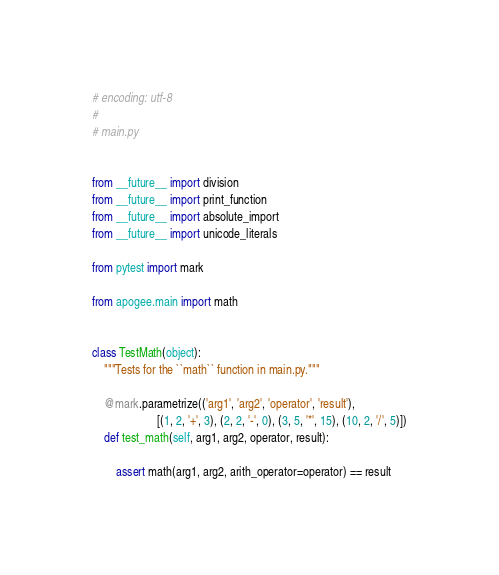Convert code to text. <code><loc_0><loc_0><loc_500><loc_500><_Python_># encoding: utf-8
#
# main.py


from __future__ import division
from __future__ import print_function
from __future__ import absolute_import
from __future__ import unicode_literals

from pytest import mark

from apogee.main import math


class TestMath(object):
    """Tests for the ``math`` function in main.py."""

    @mark.parametrize(('arg1', 'arg2', 'operator', 'result'),
                      [(1, 2, '+', 3), (2, 2, '-', 0), (3, 5, '*', 15), (10, 2, '/', 5)])
    def test_math(self, arg1, arg2, operator, result):

        assert math(arg1, arg2, arith_operator=operator) == result
</code> 